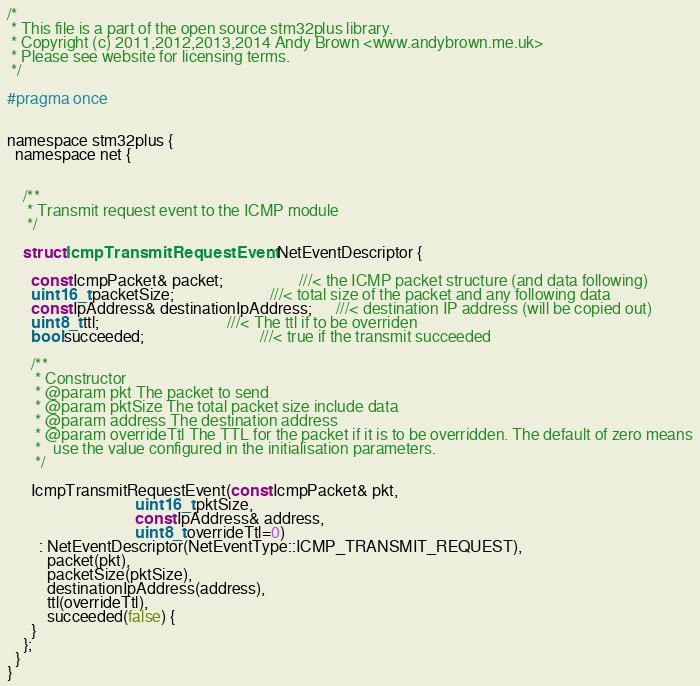Convert code to text. <code><loc_0><loc_0><loc_500><loc_500><_C_>/*
 * This file is a part of the open source stm32plus library.
 * Copyright (c) 2011,2012,2013,2014 Andy Brown <www.andybrown.me.uk>
 * Please see website for licensing terms.
 */

#pragma once


namespace stm32plus {
  namespace net {


    /**
     * Transmit request event to the ICMP module
     */

    struct IcmpTransmitRequestEvent  : NetEventDescriptor {

      const IcmpPacket& packet;                   ///< the ICMP packet structure (and data following)
      uint16_t packetSize;                        ///< total size of the packet and any following data
      const IpAddress& destinationIpAddress;      ///< destination IP address (will be copied out)
      uint8_t ttl;                                ///< The ttl if to be overriden
      bool succeeded;                             ///< true if the transmit succeeded

      /**
       * Constructor
       * @param pkt The packet to send
       * @param pktSize The total packet size include data
       * @param address The destination address
       * @param overrideTtl The TTL for the packet if it is to be overridden. The default of zero means
       *   use the value configured in the initialisation parameters.
       */

      IcmpTransmitRequestEvent(const IcmpPacket& pkt,
                                uint16_t pktSize,
                                const IpAddress& address,
                                uint8_t overrideTtl=0)
        : NetEventDescriptor(NetEventType::ICMP_TRANSMIT_REQUEST),
          packet(pkt),
          packetSize(pktSize),
          destinationIpAddress(address),
          ttl(overrideTtl),
          succeeded(false) {
      }
    };
  }
}
</code> 